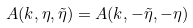Convert formula to latex. <formula><loc_0><loc_0><loc_500><loc_500>A ( k , \eta , \tilde { \eta } ) = A ( k , - \tilde { \eta } , - \eta )</formula> 